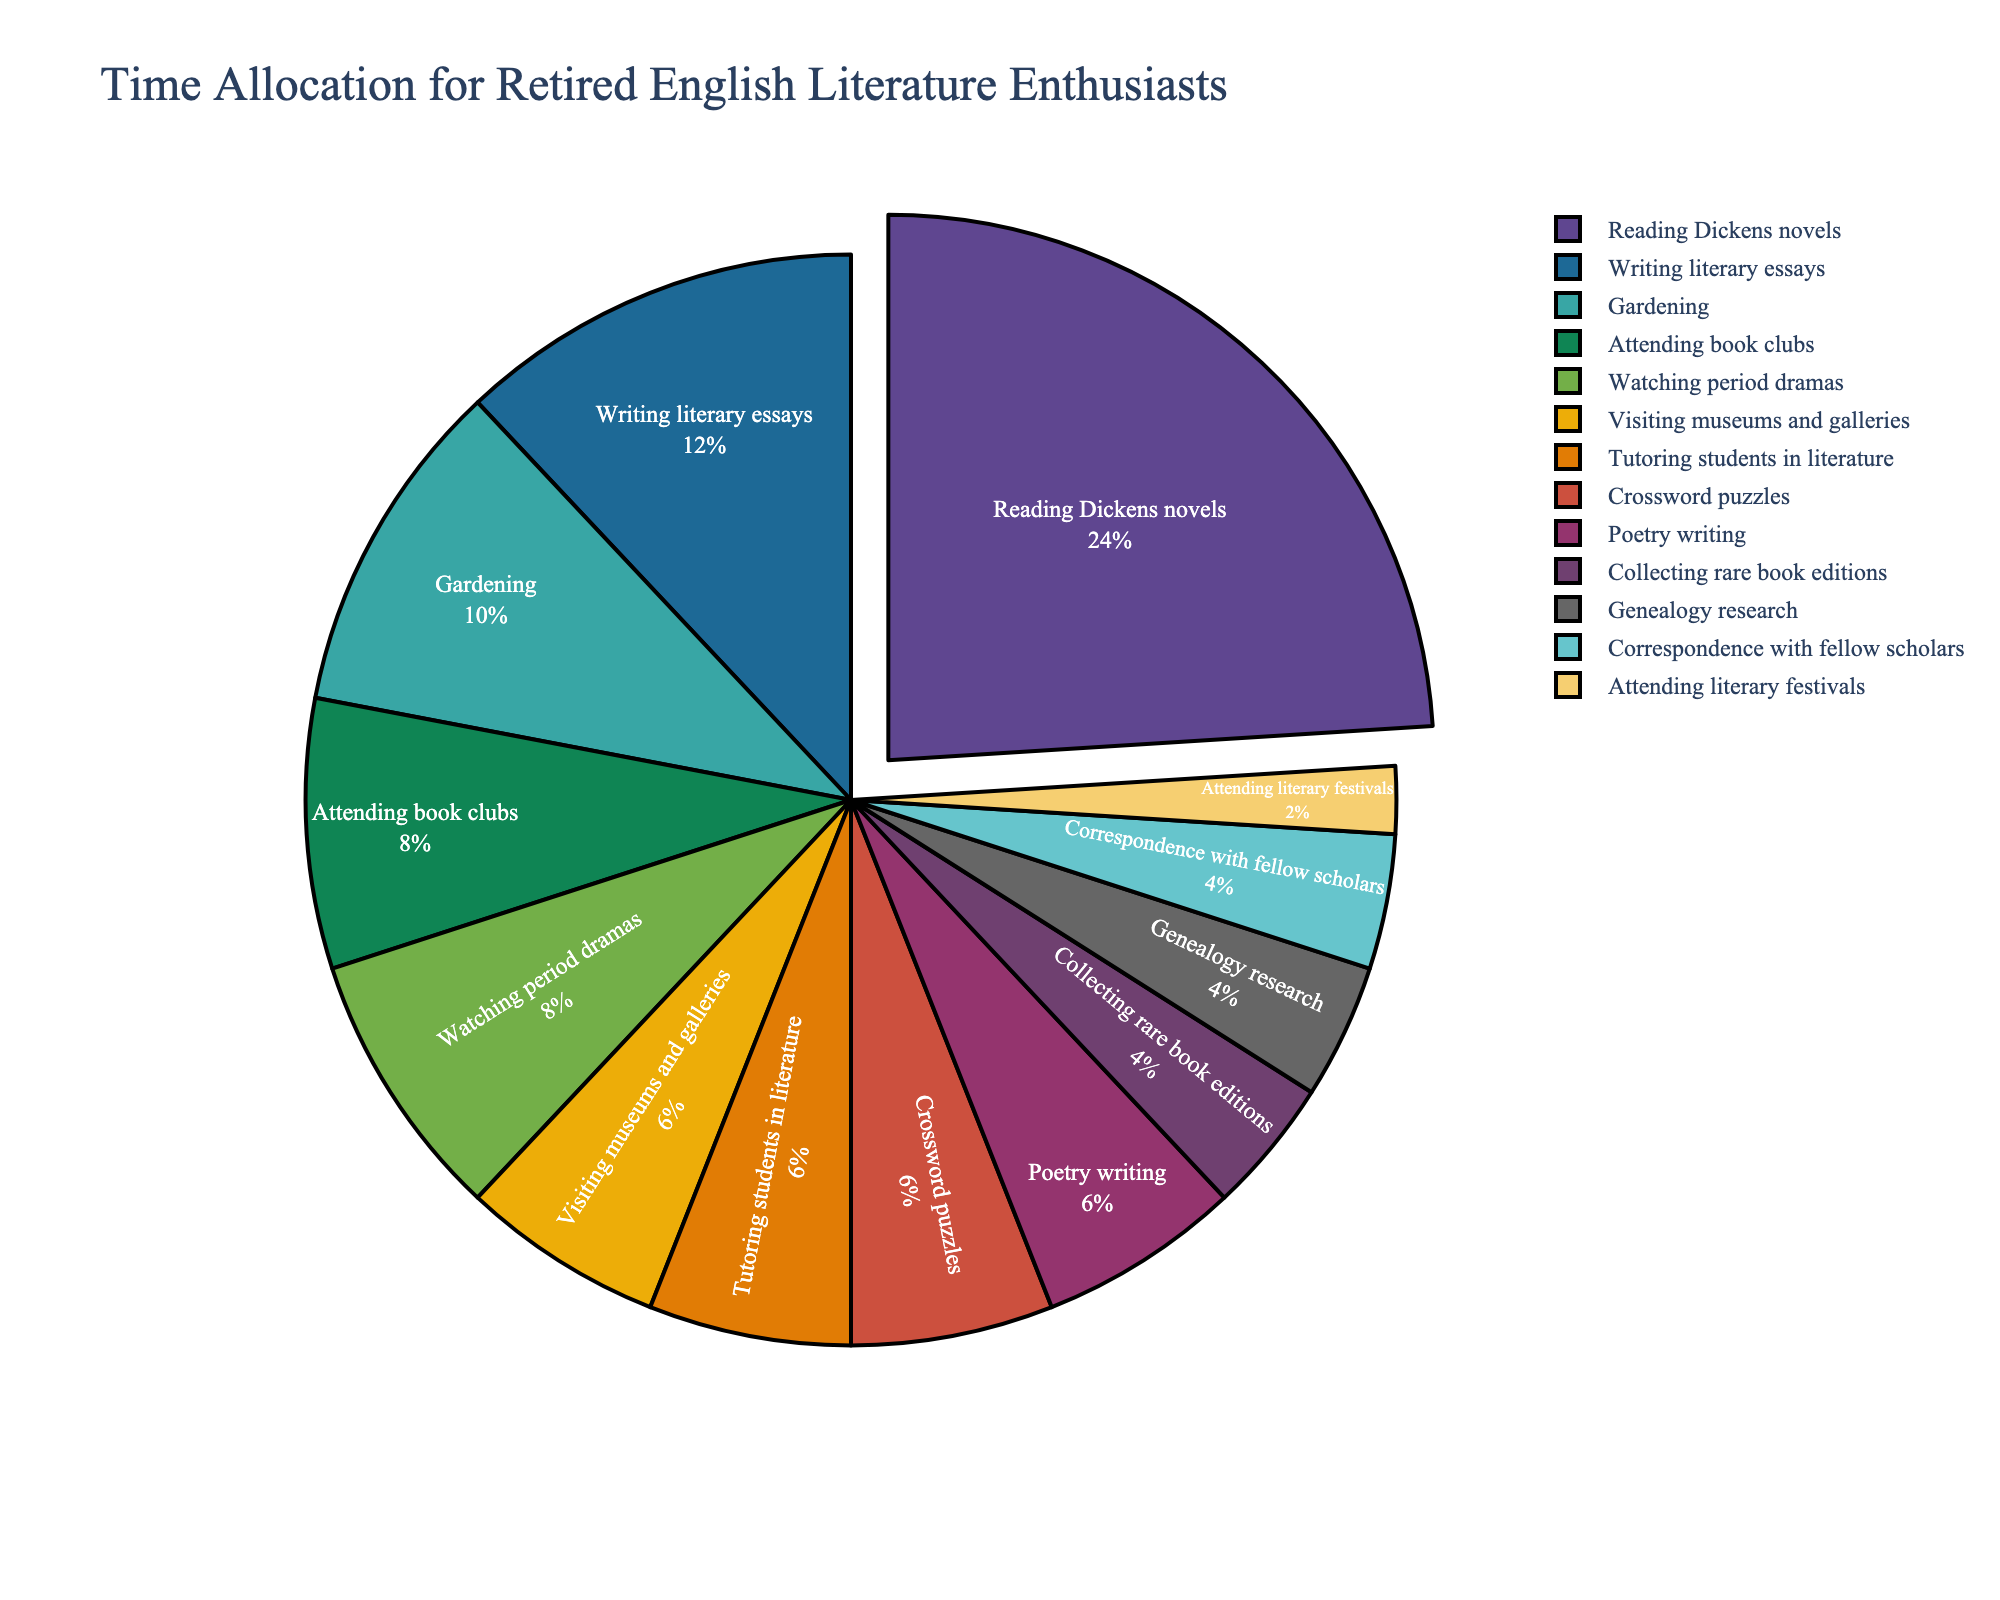What is the most time-consuming activity? The label with the largest percentage slice of the pie chart indicates the most time-consuming activity. In this chart, "Reading Dickens novels" has the largest slice.
Answer: Reading Dickens novels How much time, in total, is spent on activities with less than 4 hours per week? Identify all activities with less than 4 hours per week and sum their values. These activities are: Visiting museums and galleries (3 hours), Collecting rare book editions (2 hours), Tutoring students in literature (3 hours), Attending literary festivals (1 hour), Genealogy research (2 hours), Crossword puzzles (3 hours), Correspondence with fellow scholars (2 hours), and Poetry writing (3 hours). Total hours = 3 + 2 + 3 + 1 + 2 + 3 + 2 + 3 = 19 hours.
Answer: 19 hours Which activity shares an equal amount of time with "Watching period dramas"? Check the segments with the same size as "Watching period dramas" which is 4 hours per week. The activity with an equal time allocation is "Attending book clubs."
Answer: Attending book clubs What is the difference in hours spent between the most and least time-consuming activities? The most time-consuming activity, "Reading Dickens novels," is 12 hours per week. The least time-consuming activity, "Attending literary festivals," is 1 hour per week. The difference is 12 - 1 = 11 hours.
Answer: 11 hours How many activities have a time allocation of exactly 3 hours per week? Look at the pie chart and count the segments labeled with 3 hours per week. These activities are: Visiting museums and galleries, Tutoring students in literature, Crossword puzzles, and Poetry writing. The total count is 4.
Answer: 4 